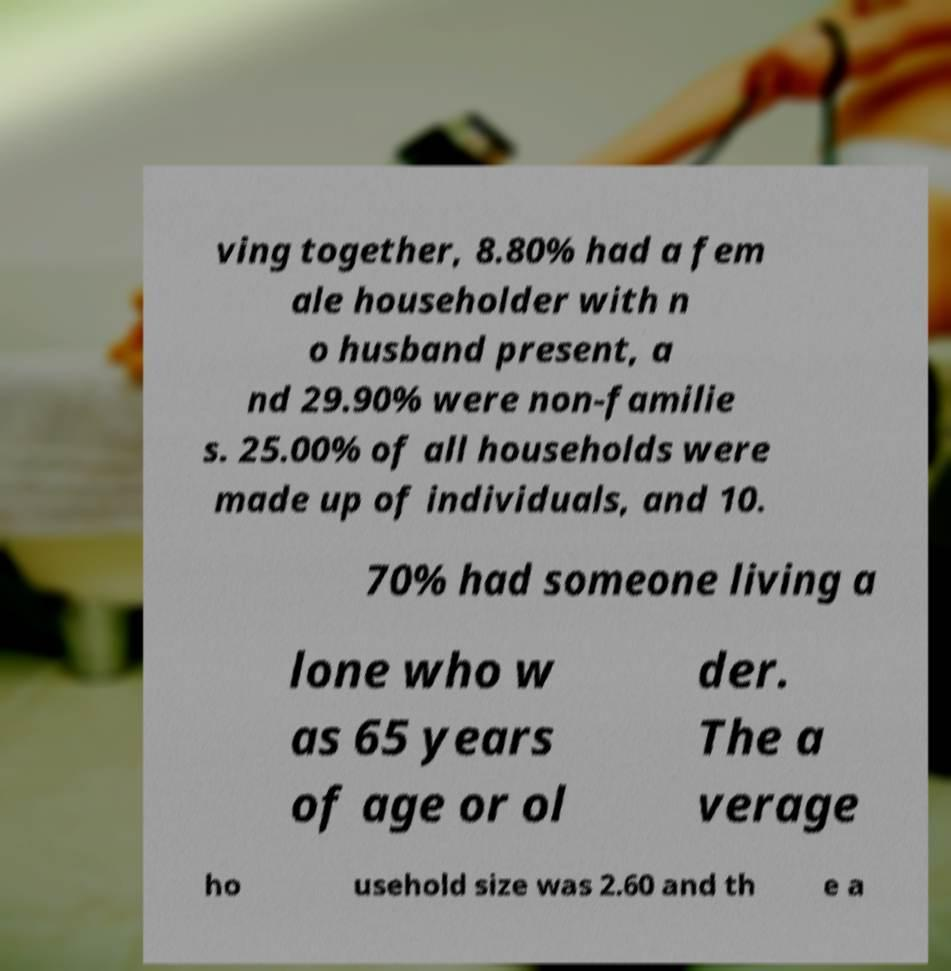Could you extract and type out the text from this image? ving together, 8.80% had a fem ale householder with n o husband present, a nd 29.90% were non-familie s. 25.00% of all households were made up of individuals, and 10. 70% had someone living a lone who w as 65 years of age or ol der. The a verage ho usehold size was 2.60 and th e a 